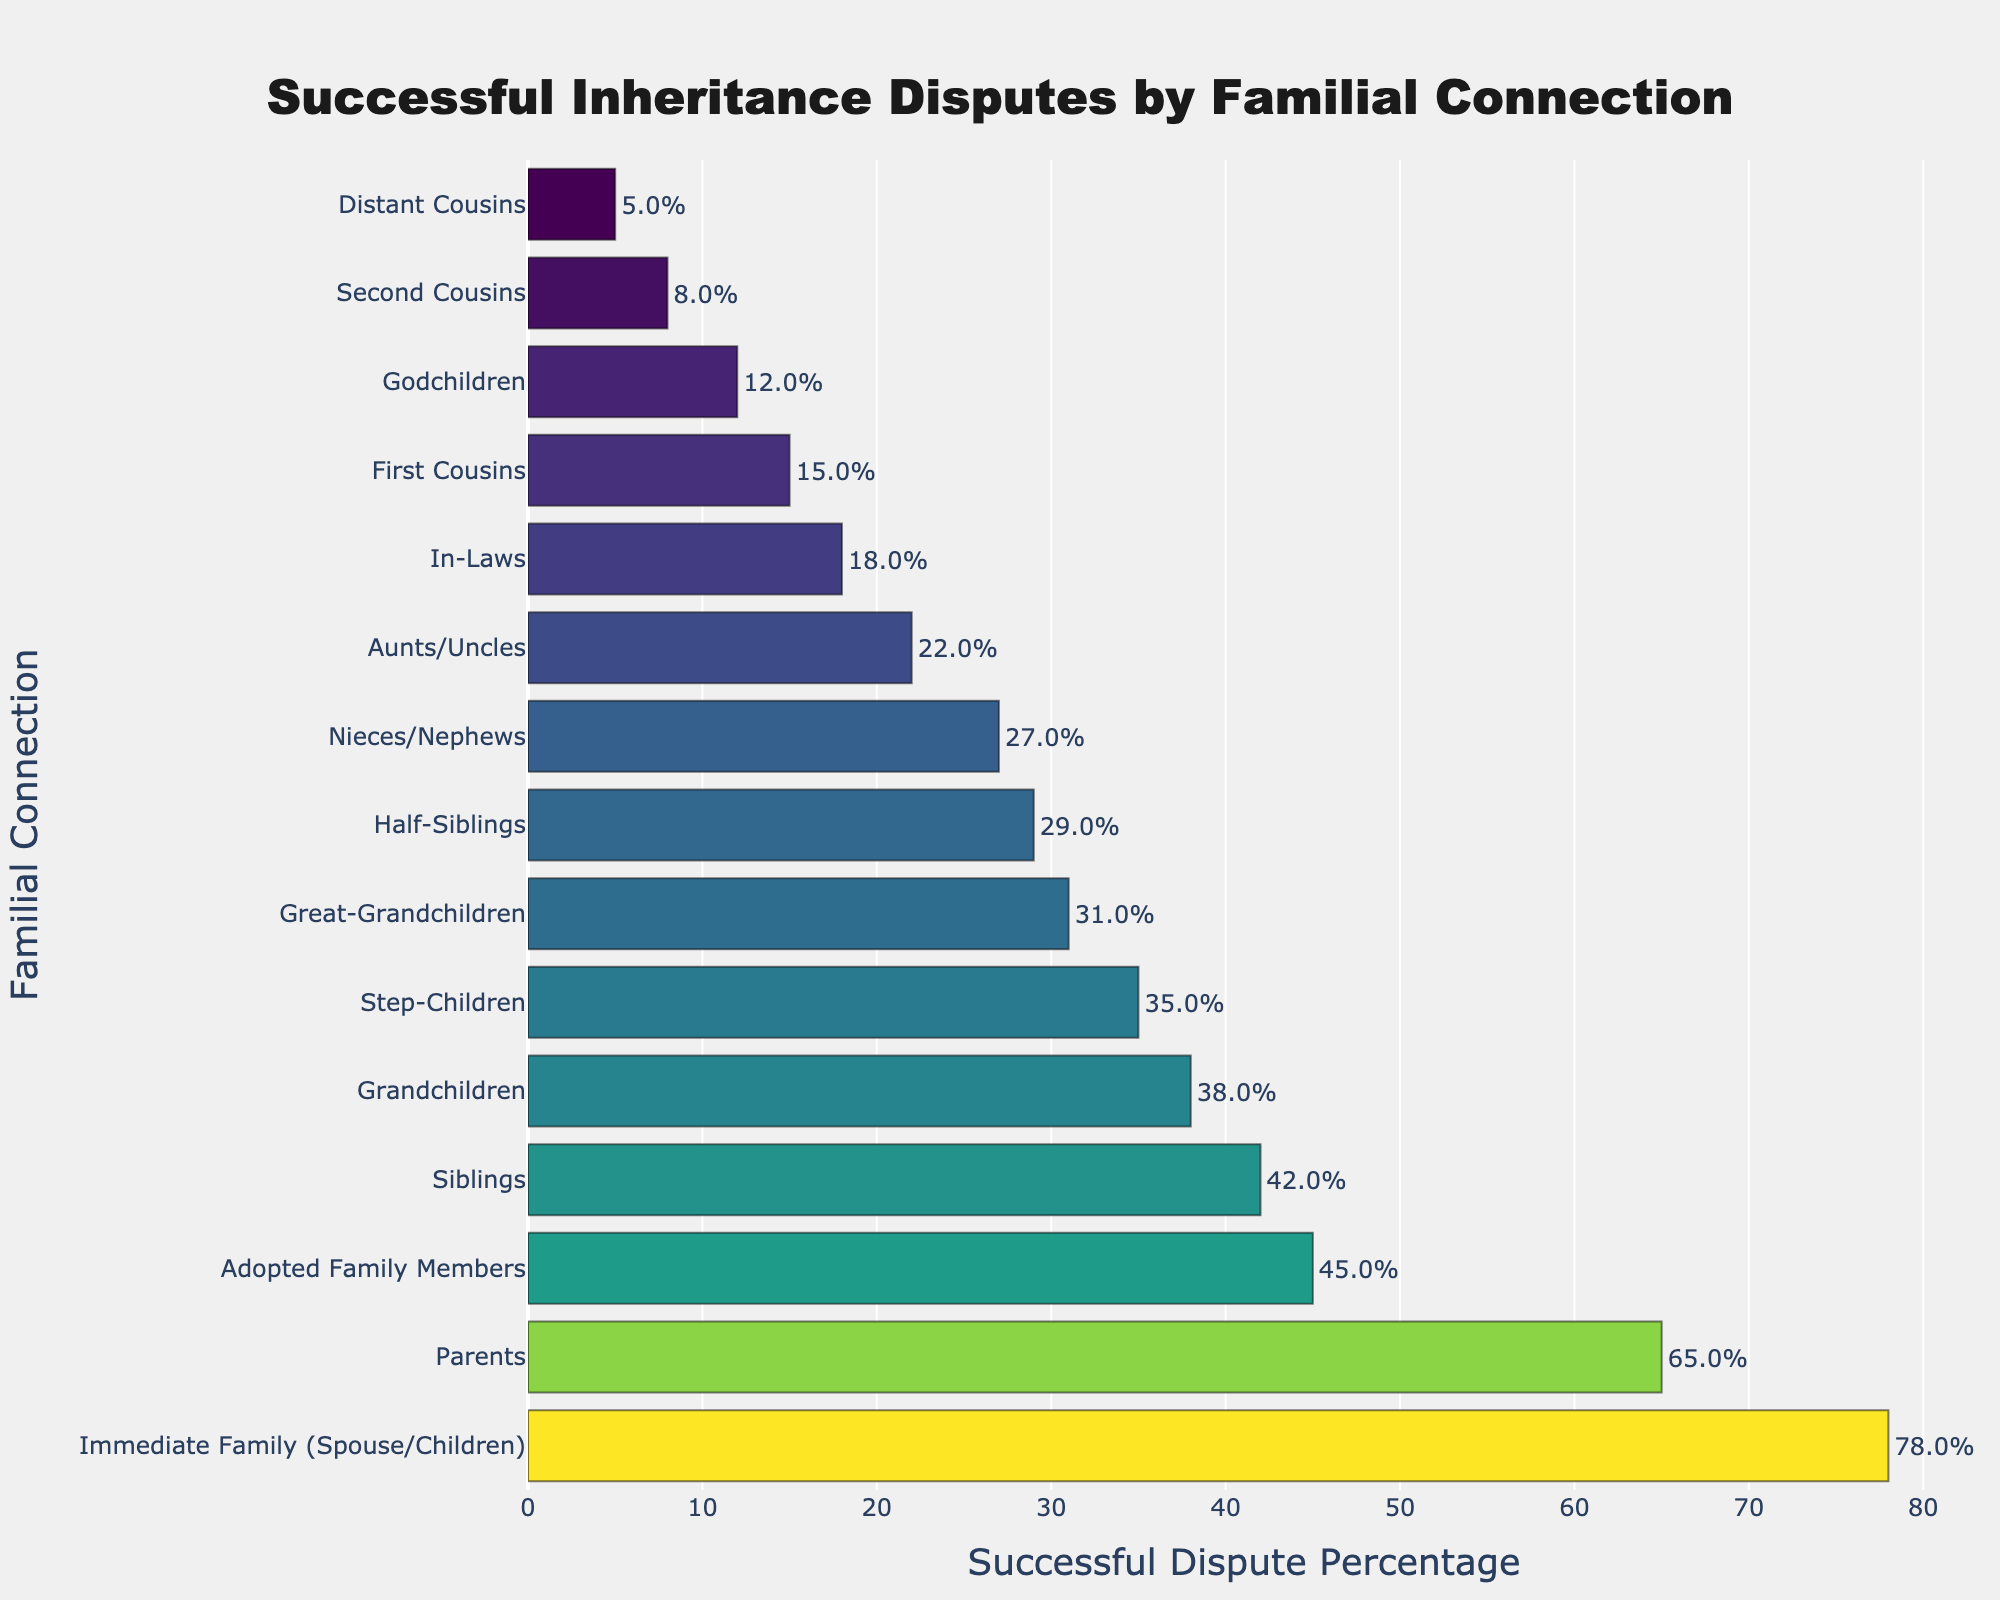What familial connection has the highest percentage of successful inheritance disputes? The highest bar represents the 'Immediate Family (Spouse/Children)' category, indicating it has the highest percentage.
Answer: Immediate Family (Spouse/Children) Which familial connection has a higher successful dispute percentage, Nieces/Nephews or Step-Children? Comparing the heights of the bars for 'Nieces/Nephews' and 'Step-Children', the 'Step-Children' bar is higher.
Answer: Step-Children What is the difference in successful dispute percentage between Immediate Family (Spouse/Children) and Second Cousins? Subtract the percentage for Second Cousins from Immediate Family (Spouse/Children): 78% - 8% = 70%.
Answer: 70% What is the median successful dispute percentage? Sort the percentages in ascending order and find the middle value. With 15 data points, the median is at position 8. The sorted percentages are: 5, 8, 12, 15, 18, 22, 27, 29, 31, 35, 38, 42, 45, 65, 78. The middle value is 29 (Half-Siblings).
Answer: 29 How many familial connections have a successful dispute percentage of 30% or higher? Count the bars that are equal to or above 30%: Immediate Family (78%), Parents (65%), Adopted Family Members (45%), Siblings (42%), Step-Children (35%), Great-Grandchildren (31%), and Half-Siblings (29%) are close but below. So, there are 6 bars.
Answer: 6 Which familial connection has the lowest percentage of successful inheritance disputes? The shortest bar represents the 'Distant Cousins' category with 5%.
Answer: Distant Cousins What is the average successful dispute percentage for Godchildren, In-Laws, and Adopted Family Members combined? Add the percentages for these groups and divide by 3: (12% + 18% + 45%) / 3 = 75% / 3 = 25%.
Answer: 25 Is the successful dispute percentage for Parents more than twice that of First Cousins? First Cousins have 15%. Twice this value is 30%. As Parents have 65%, which is more than twice 15%.
Answer: Yes Which has a higher successful dispute percentage: Grandchildren or Godchildren? Compare the heights of the bars for 'Grandchildren' and 'Godchildren', the 'Grandchildren' bar is higher.
Answer: Grandchildren How much lower is the successful dispute percentage for Great-Grandchildren compared to Parents? Subtract the percentage of Great-Grandchildren from Parents: 65% - 31% = 34%.
Answer: 34 